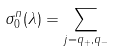<formula> <loc_0><loc_0><loc_500><loc_500>\sigma _ { 0 } ^ { n } ( \lambda ) = \sum _ { j = q _ { + } , q _ { - } }</formula> 